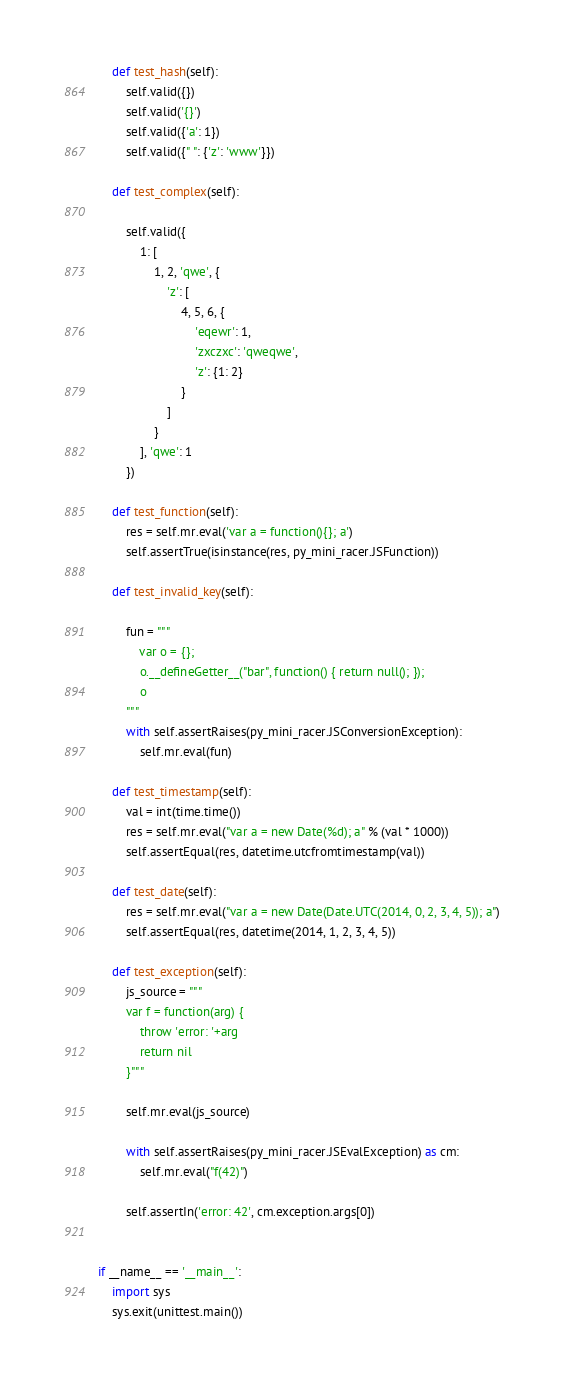<code> <loc_0><loc_0><loc_500><loc_500><_Python_>    def test_hash(self):
        self.valid({})
        self.valid('{}')
        self.valid({'a': 1})
        self.valid({" ": {'z': 'www'}})

    def test_complex(self):

        self.valid({
            1: [
                1, 2, 'qwe', {
                    'z': [
                        4, 5, 6, {
                            'eqewr': 1,
                            'zxczxc': 'qweqwe',
                            'z': {1: 2}
                        }
                    ]
                }
            ], 'qwe': 1
        })

    def test_function(self):
        res = self.mr.eval('var a = function(){}; a')
        self.assertTrue(isinstance(res, py_mini_racer.JSFunction))

    def test_invalid_key(self):

        fun = """
            var o = {};
            o.__defineGetter__("bar", function() { return null(); });
            o
        """
        with self.assertRaises(py_mini_racer.JSConversionException):
            self.mr.eval(fun)

    def test_timestamp(self):
        val = int(time.time())
        res = self.mr.eval("var a = new Date(%d); a" % (val * 1000))
        self.assertEqual(res, datetime.utcfromtimestamp(val))

    def test_date(self):
        res = self.mr.eval("var a = new Date(Date.UTC(2014, 0, 2, 3, 4, 5)); a")
        self.assertEqual(res, datetime(2014, 1, 2, 3, 4, 5))

    def test_exception(self):
        js_source = """
        var f = function(arg) {
            throw 'error: '+arg
            return nil
        }"""

        self.mr.eval(js_source)

        with self.assertRaises(py_mini_racer.JSEvalException) as cm:
            self.mr.eval("f(42)")

        self.assertIn('error: 42', cm.exception.args[0])


if __name__ == '__main__':
    import sys
    sys.exit(unittest.main())
</code> 